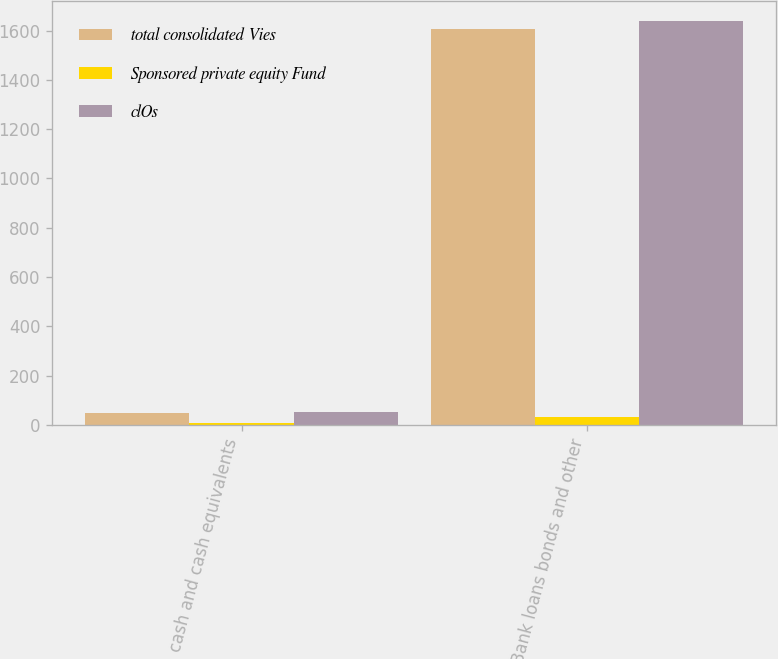Convert chart to OTSL. <chart><loc_0><loc_0><loc_500><loc_500><stacked_bar_chart><ecel><fcel>cash and cash equivalents<fcel>Bank loans bonds and other<nl><fcel>total consolidated Vies<fcel>47<fcel>1608<nl><fcel>Sponsored private equity Fund<fcel>7<fcel>31<nl><fcel>clOs<fcel>54<fcel>1639<nl></chart> 